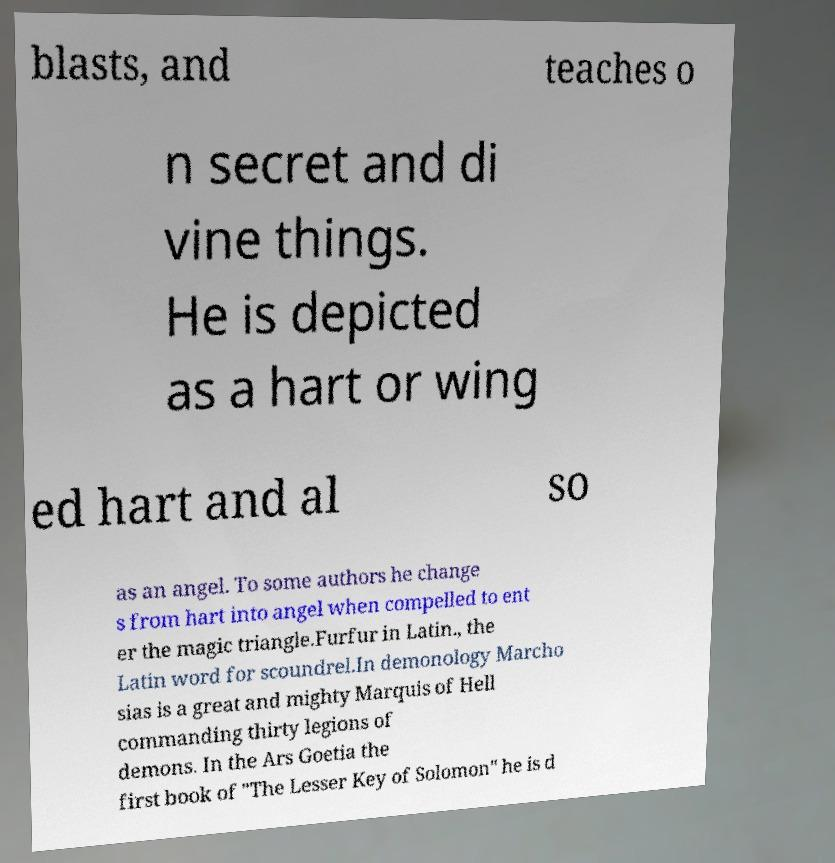There's text embedded in this image that I need extracted. Can you transcribe it verbatim? blasts, and teaches o n secret and di vine things. He is depicted as a hart or wing ed hart and al so as an angel. To some authors he change s from hart into angel when compelled to ent er the magic triangle.Furfur in Latin., the Latin word for scoundrel.In demonology Marcho sias is a great and mighty Marquis of Hell commanding thirty legions of demons. In the Ars Goetia the first book of "The Lesser Key of Solomon" he is d 